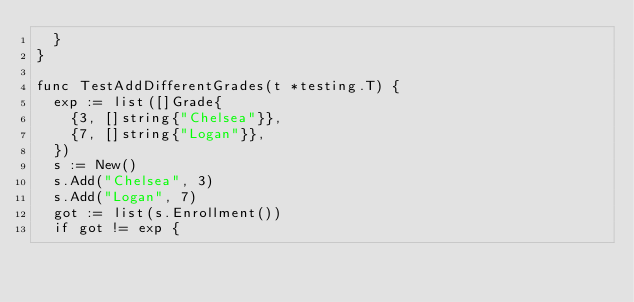Convert code to text. <code><loc_0><loc_0><loc_500><loc_500><_Go_>	}
}

func TestAddDifferentGrades(t *testing.T) {
	exp := list([]Grade{
		{3, []string{"Chelsea"}},
		{7, []string{"Logan"}},
	})
	s := New()
	s.Add("Chelsea", 3)
	s.Add("Logan", 7)
	got := list(s.Enrollment())
	if got != exp {</code> 